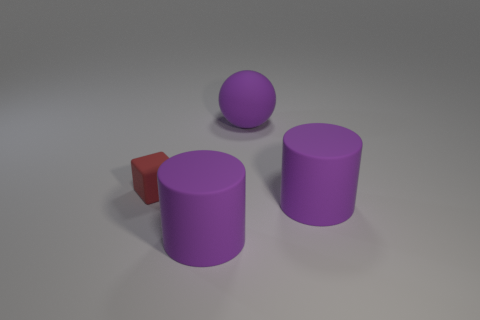Add 4 metallic cubes. How many objects exist? 8 Subtract all spheres. How many objects are left? 3 Subtract all matte spheres. Subtract all large purple objects. How many objects are left? 0 Add 3 purple cylinders. How many purple cylinders are left? 5 Add 1 large balls. How many large balls exist? 2 Subtract 1 purple balls. How many objects are left? 3 